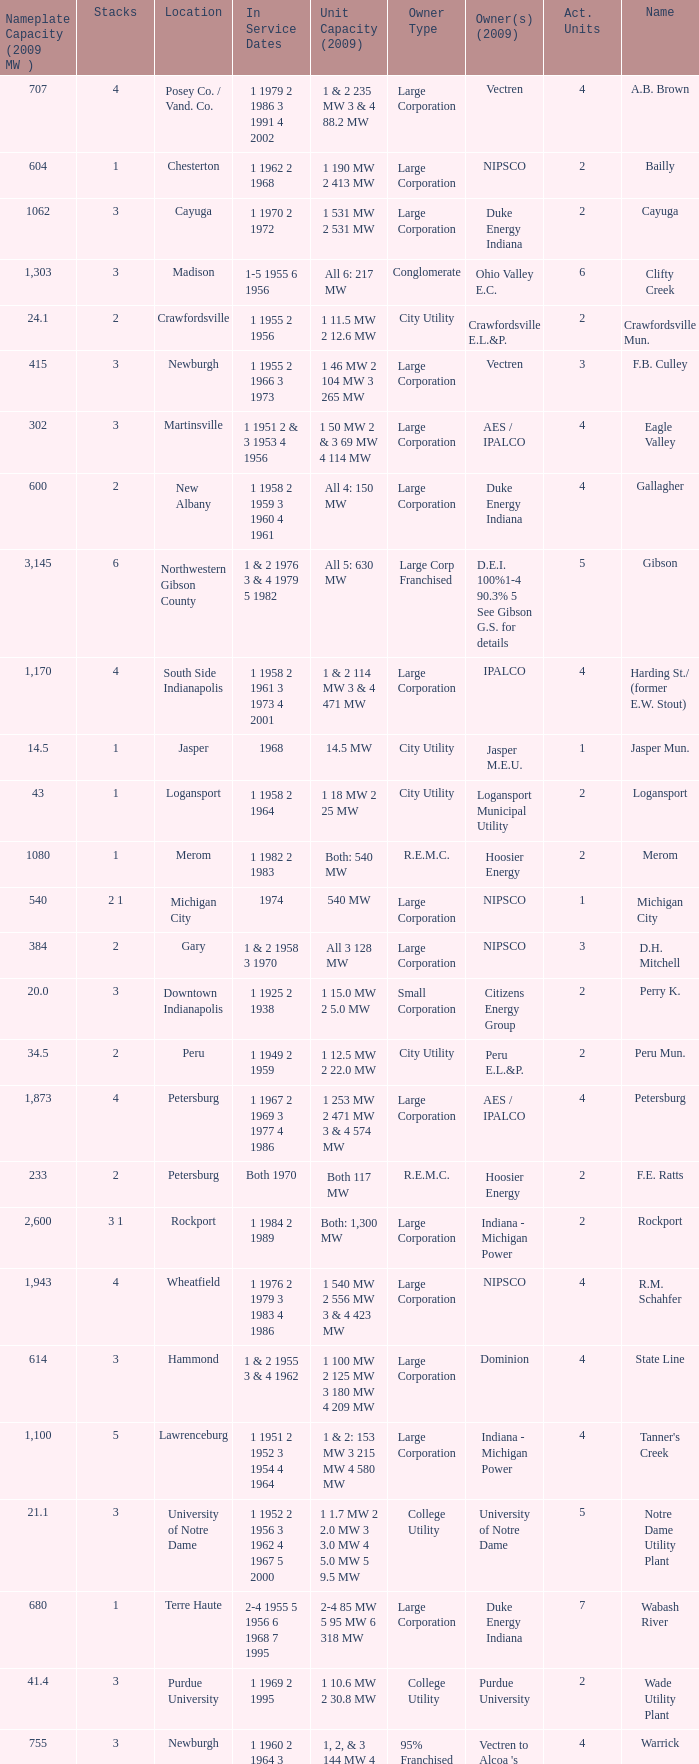Name the number of stacks for 1 & 2 235 mw 3 & 4 88.2 mw 1.0. 